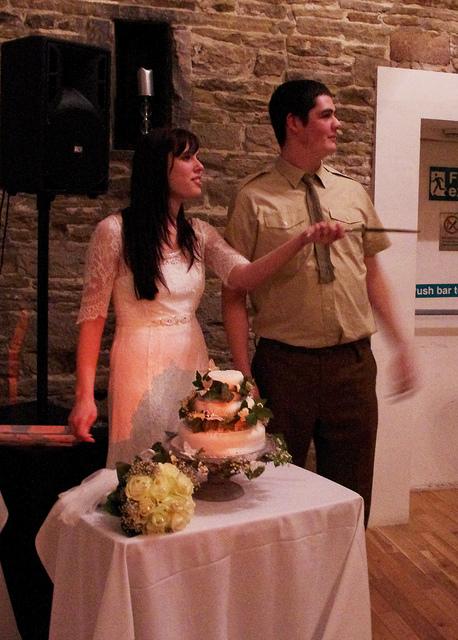What is this lady doing?
Short answer required. Pointing. Is the woman smiling at you?
Give a very brief answer. No. What is the couple celebrating?
Write a very short answer. Wedding. How many people in the shot?
Keep it brief. 2. Is this a whole cake?
Answer briefly. Yes. What utensil is the woman holding?
Answer briefly. Knife. What are the tables made of?
Quick response, please. Wood. Are they having dinner?
Keep it brief. No. What hairstyle does the woman wear?
Short answer required. Down. What color is the cake?
Write a very short answer. White. What is the woman holding?
Give a very brief answer. Knife. What are the people doing?
Keep it brief. Standing. Is the yellow object next to the cake on the table, a gift?
Short answer required. No. What flavor does the cake look like?
Short answer required. Vanilla. What design is on the skirt?
Keep it brief. Lace. What is the man doing?
Give a very brief answer. Standing. What flavor is the cake?
Quick response, please. Vanilla. Is she a hula dancer?
Be succinct. No. Are the people happy?
Concise answer only. Yes. Is smoking cigarettes allowed here?
Short answer required. No. What is the woman holding in her left hand?
Write a very short answer. Knife. Does the man have hair?
Concise answer only. Yes. How many layers does the cake have?
Write a very short answer. 3. What color is the knife handle?
Write a very short answer. Black. What is the woman in the photo celebrating?
Short answer required. Wedding. Is this a diplomatic celebration?
Write a very short answer. No. Is a knife visible in this picture?
Write a very short answer. Yes. 